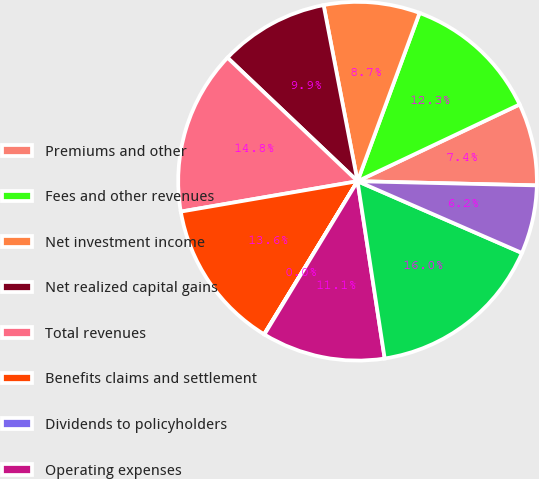Convert chart to OTSL. <chart><loc_0><loc_0><loc_500><loc_500><pie_chart><fcel>Premiums and other<fcel>Fees and other revenues<fcel>Net investment income<fcel>Net realized capital gains<fcel>Total revenues<fcel>Benefits claims and settlement<fcel>Dividends to policyholders<fcel>Operating expenses<fcel>Total expenses<fcel>Income from continuing<nl><fcel>7.41%<fcel>12.34%<fcel>8.65%<fcel>9.88%<fcel>14.8%<fcel>13.57%<fcel>0.03%<fcel>11.11%<fcel>16.03%<fcel>6.18%<nl></chart> 